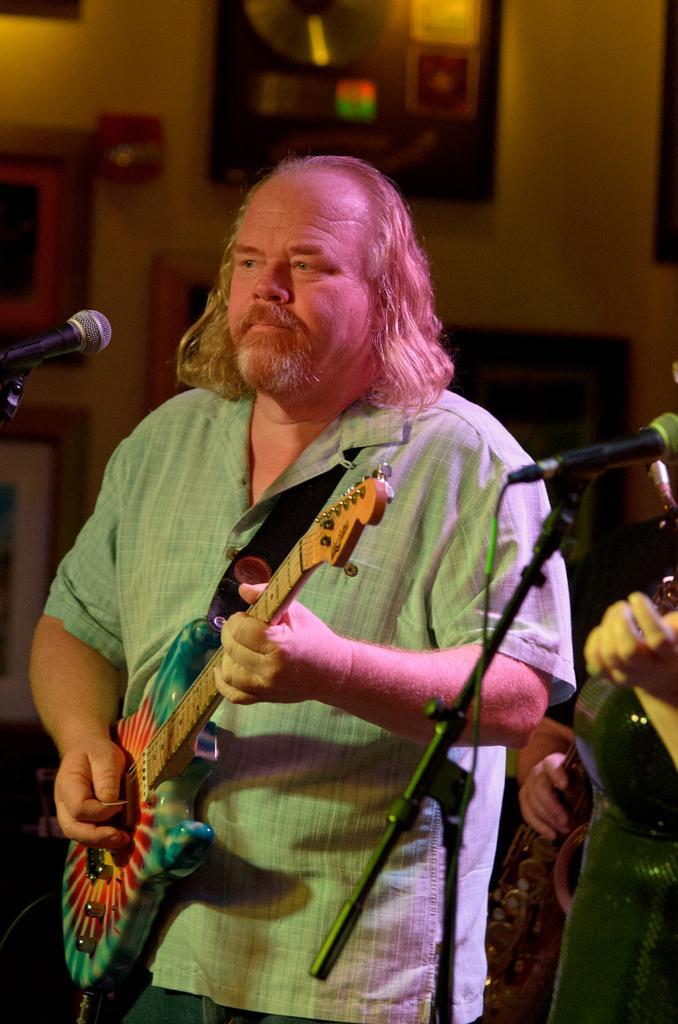Please provide a concise description of this image. In this image there are two people , In the middle a man holding a guitar and steering something he wear a check shirt and trouser, in front of him there is a mic. In the background there is a wall and photo frame. 